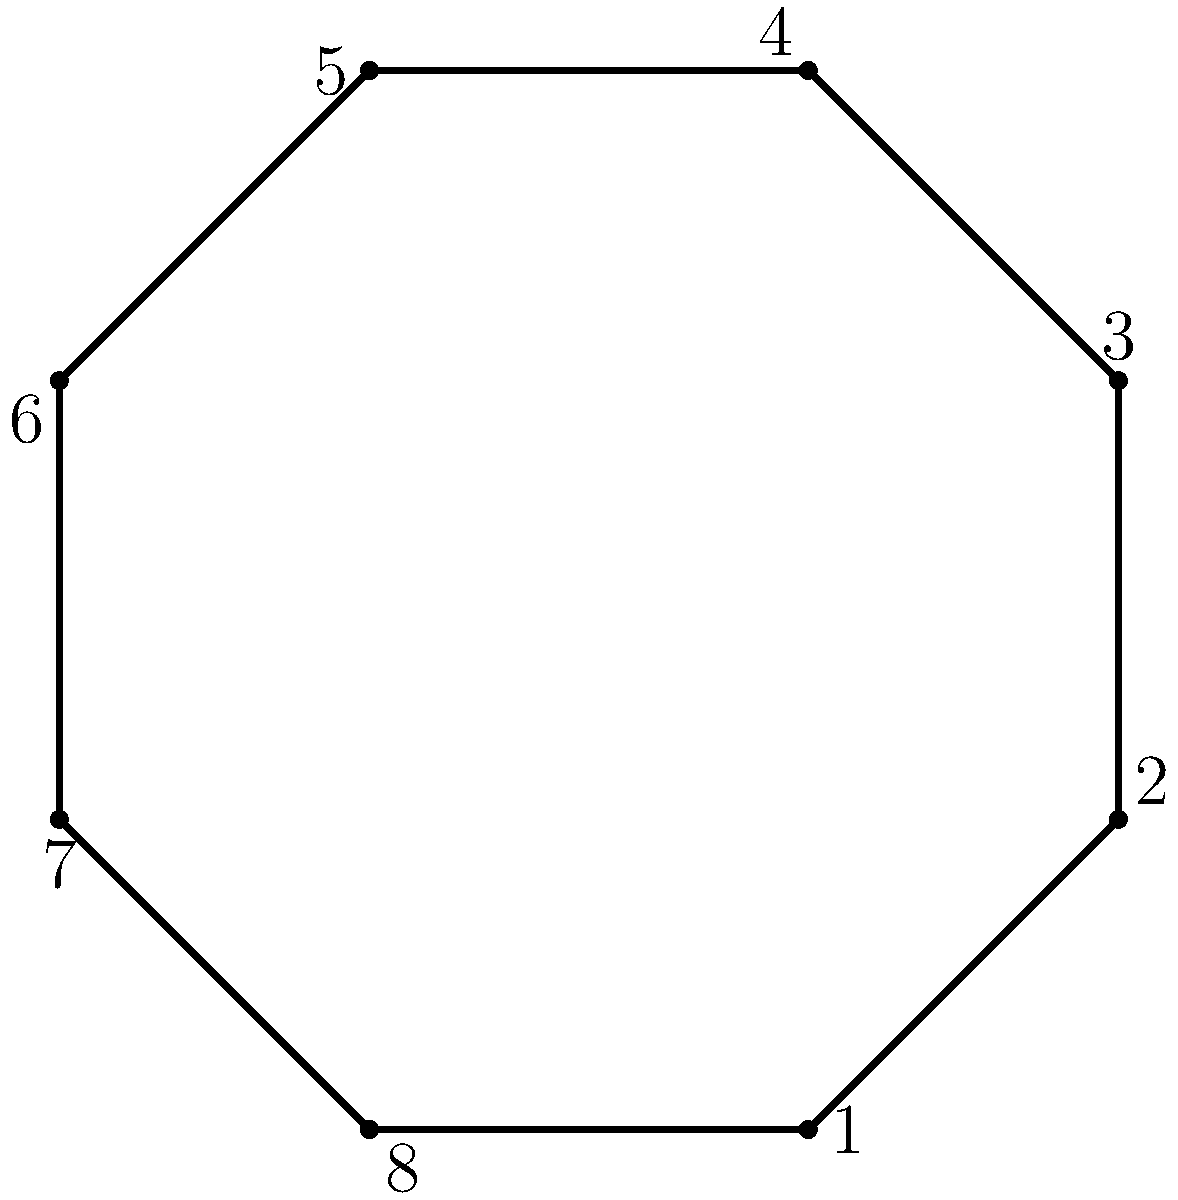The iconic porch of the Grand Hotel on Mackinac Island has an octagonal shape, as shown in the diagram. Each vertex is numbered from 1 to 8. If we consider the rotational symmetry of this shape, what is the order of the rotation group for this porch structure? Additionally, what is the smallest non-identity rotation (in degrees) that maps the porch onto itself? To solve this problem, let's follow these steps:

1. Identify the symmetry: The porch has an octagonal shape, which means it has 8-fold rotational symmetry.

2. Determine the order of the rotation group:
   - The order of a rotation group is the number of unique rotations that map the shape onto itself, including the identity rotation.
   - For an octagon, we have:
     a) Identity rotation (0°)
     b) 45° rotation
     c) 90° rotation
     d) 135° rotation
     e) 180° rotation
     f) 225° rotation
     g) 270° rotation
     h) 315° rotation
   - Therefore, the order of the rotation group is 8.

3. Find the smallest non-identity rotation:
   - The smallest rotation that maps the octagon onto itself is 360° ÷ 8 = 45°.

This rotation of 45° corresponds to moving each numbered vertex to the next position clockwise. For example, vertex 1 would move to the position of vertex 8, vertex 2 to the position of vertex 1, and so on.

The group of rotational symmetries of the octagon is isomorphic to the cyclic group $C_8$, which has order 8 and is generated by the 45° rotation.
Answer: Order: 8; Smallest non-identity rotation: 45° 